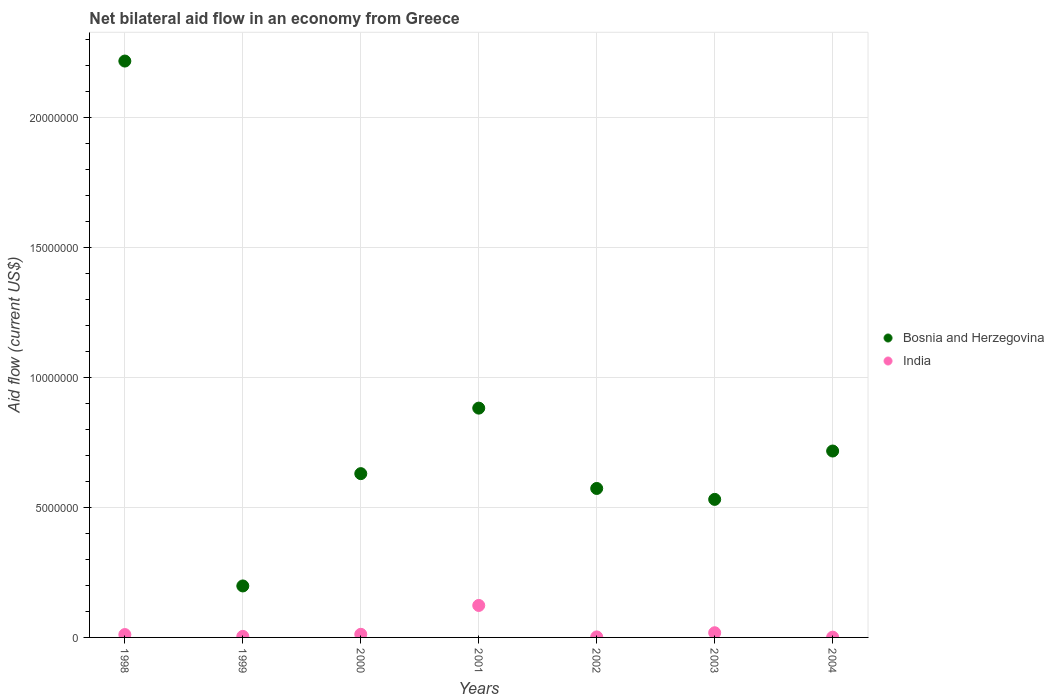How many different coloured dotlines are there?
Your response must be concise. 2. Across all years, what is the maximum net bilateral aid flow in Bosnia and Herzegovina?
Give a very brief answer. 2.22e+07. Across all years, what is the minimum net bilateral aid flow in India?
Offer a terse response. 10000. In which year was the net bilateral aid flow in Bosnia and Herzegovina maximum?
Your response must be concise. 1998. What is the total net bilateral aid flow in Bosnia and Herzegovina in the graph?
Offer a terse response. 5.75e+07. What is the difference between the net bilateral aid flow in Bosnia and Herzegovina in 1999 and that in 2002?
Make the answer very short. -3.75e+06. What is the difference between the net bilateral aid flow in Bosnia and Herzegovina in 1998 and the net bilateral aid flow in India in 2002?
Make the answer very short. 2.22e+07. What is the average net bilateral aid flow in Bosnia and Herzegovina per year?
Offer a very short reply. 8.21e+06. In the year 2002, what is the difference between the net bilateral aid flow in India and net bilateral aid flow in Bosnia and Herzegovina?
Give a very brief answer. -5.71e+06. What is the ratio of the net bilateral aid flow in India in 2000 to that in 2003?
Offer a terse response. 0.67. Is the difference between the net bilateral aid flow in India in 2000 and 2004 greater than the difference between the net bilateral aid flow in Bosnia and Herzegovina in 2000 and 2004?
Offer a terse response. Yes. What is the difference between the highest and the second highest net bilateral aid flow in Bosnia and Herzegovina?
Provide a succinct answer. 1.34e+07. What is the difference between the highest and the lowest net bilateral aid flow in India?
Give a very brief answer. 1.22e+06. Is the sum of the net bilateral aid flow in Bosnia and Herzegovina in 1999 and 2001 greater than the maximum net bilateral aid flow in India across all years?
Your answer should be compact. Yes. Does the net bilateral aid flow in Bosnia and Herzegovina monotonically increase over the years?
Provide a short and direct response. No. Is the net bilateral aid flow in Bosnia and Herzegovina strictly less than the net bilateral aid flow in India over the years?
Offer a terse response. No. How many dotlines are there?
Provide a succinct answer. 2. What is the difference between two consecutive major ticks on the Y-axis?
Offer a very short reply. 5.00e+06. Are the values on the major ticks of Y-axis written in scientific E-notation?
Provide a short and direct response. No. Does the graph contain grids?
Offer a terse response. Yes. Where does the legend appear in the graph?
Provide a succinct answer. Center right. How many legend labels are there?
Your answer should be compact. 2. How are the legend labels stacked?
Offer a terse response. Vertical. What is the title of the graph?
Ensure brevity in your answer.  Net bilateral aid flow in an economy from Greece. What is the label or title of the X-axis?
Your response must be concise. Years. What is the label or title of the Y-axis?
Provide a succinct answer. Aid flow (current US$). What is the Aid flow (current US$) of Bosnia and Herzegovina in 1998?
Your response must be concise. 2.22e+07. What is the Aid flow (current US$) of India in 1998?
Your answer should be compact. 1.10e+05. What is the Aid flow (current US$) in Bosnia and Herzegovina in 1999?
Provide a succinct answer. 1.98e+06. What is the Aid flow (current US$) in Bosnia and Herzegovina in 2000?
Ensure brevity in your answer.  6.30e+06. What is the Aid flow (current US$) of Bosnia and Herzegovina in 2001?
Ensure brevity in your answer.  8.82e+06. What is the Aid flow (current US$) of India in 2001?
Keep it short and to the point. 1.23e+06. What is the Aid flow (current US$) of Bosnia and Herzegovina in 2002?
Provide a short and direct response. 5.73e+06. What is the Aid flow (current US$) in Bosnia and Herzegovina in 2003?
Make the answer very short. 5.31e+06. What is the Aid flow (current US$) of Bosnia and Herzegovina in 2004?
Provide a succinct answer. 7.17e+06. What is the Aid flow (current US$) in India in 2004?
Give a very brief answer. 10000. Across all years, what is the maximum Aid flow (current US$) in Bosnia and Herzegovina?
Your answer should be compact. 2.22e+07. Across all years, what is the maximum Aid flow (current US$) of India?
Offer a very short reply. 1.23e+06. Across all years, what is the minimum Aid flow (current US$) of Bosnia and Herzegovina?
Offer a terse response. 1.98e+06. Across all years, what is the minimum Aid flow (current US$) of India?
Your response must be concise. 10000. What is the total Aid flow (current US$) in Bosnia and Herzegovina in the graph?
Provide a succinct answer. 5.75e+07. What is the total Aid flow (current US$) in India in the graph?
Your answer should be very brief. 1.71e+06. What is the difference between the Aid flow (current US$) of Bosnia and Herzegovina in 1998 and that in 1999?
Your answer should be compact. 2.02e+07. What is the difference between the Aid flow (current US$) of India in 1998 and that in 1999?
Your response must be concise. 7.00e+04. What is the difference between the Aid flow (current US$) of Bosnia and Herzegovina in 1998 and that in 2000?
Offer a very short reply. 1.59e+07. What is the difference between the Aid flow (current US$) of India in 1998 and that in 2000?
Offer a terse response. -10000. What is the difference between the Aid flow (current US$) in Bosnia and Herzegovina in 1998 and that in 2001?
Ensure brevity in your answer.  1.34e+07. What is the difference between the Aid flow (current US$) of India in 1998 and that in 2001?
Provide a short and direct response. -1.12e+06. What is the difference between the Aid flow (current US$) of Bosnia and Herzegovina in 1998 and that in 2002?
Your response must be concise. 1.64e+07. What is the difference between the Aid flow (current US$) in India in 1998 and that in 2002?
Keep it short and to the point. 9.00e+04. What is the difference between the Aid flow (current US$) in Bosnia and Herzegovina in 1998 and that in 2003?
Your answer should be very brief. 1.69e+07. What is the difference between the Aid flow (current US$) in India in 1998 and that in 2003?
Your answer should be very brief. -7.00e+04. What is the difference between the Aid flow (current US$) of Bosnia and Herzegovina in 1998 and that in 2004?
Offer a very short reply. 1.50e+07. What is the difference between the Aid flow (current US$) in India in 1998 and that in 2004?
Your response must be concise. 1.00e+05. What is the difference between the Aid flow (current US$) of Bosnia and Herzegovina in 1999 and that in 2000?
Offer a terse response. -4.32e+06. What is the difference between the Aid flow (current US$) in India in 1999 and that in 2000?
Keep it short and to the point. -8.00e+04. What is the difference between the Aid flow (current US$) of Bosnia and Herzegovina in 1999 and that in 2001?
Your answer should be compact. -6.84e+06. What is the difference between the Aid flow (current US$) in India in 1999 and that in 2001?
Provide a short and direct response. -1.19e+06. What is the difference between the Aid flow (current US$) of Bosnia and Herzegovina in 1999 and that in 2002?
Offer a terse response. -3.75e+06. What is the difference between the Aid flow (current US$) in Bosnia and Herzegovina in 1999 and that in 2003?
Give a very brief answer. -3.33e+06. What is the difference between the Aid flow (current US$) in Bosnia and Herzegovina in 1999 and that in 2004?
Offer a terse response. -5.19e+06. What is the difference between the Aid flow (current US$) of India in 1999 and that in 2004?
Your response must be concise. 3.00e+04. What is the difference between the Aid flow (current US$) of Bosnia and Herzegovina in 2000 and that in 2001?
Ensure brevity in your answer.  -2.52e+06. What is the difference between the Aid flow (current US$) in India in 2000 and that in 2001?
Provide a succinct answer. -1.11e+06. What is the difference between the Aid flow (current US$) of Bosnia and Herzegovina in 2000 and that in 2002?
Keep it short and to the point. 5.70e+05. What is the difference between the Aid flow (current US$) in India in 2000 and that in 2002?
Your answer should be compact. 1.00e+05. What is the difference between the Aid flow (current US$) of Bosnia and Herzegovina in 2000 and that in 2003?
Keep it short and to the point. 9.90e+05. What is the difference between the Aid flow (current US$) in Bosnia and Herzegovina in 2000 and that in 2004?
Keep it short and to the point. -8.70e+05. What is the difference between the Aid flow (current US$) of India in 2000 and that in 2004?
Give a very brief answer. 1.10e+05. What is the difference between the Aid flow (current US$) of Bosnia and Herzegovina in 2001 and that in 2002?
Provide a succinct answer. 3.09e+06. What is the difference between the Aid flow (current US$) in India in 2001 and that in 2002?
Make the answer very short. 1.21e+06. What is the difference between the Aid flow (current US$) in Bosnia and Herzegovina in 2001 and that in 2003?
Make the answer very short. 3.51e+06. What is the difference between the Aid flow (current US$) of India in 2001 and that in 2003?
Make the answer very short. 1.05e+06. What is the difference between the Aid flow (current US$) in Bosnia and Herzegovina in 2001 and that in 2004?
Your answer should be very brief. 1.65e+06. What is the difference between the Aid flow (current US$) of India in 2001 and that in 2004?
Give a very brief answer. 1.22e+06. What is the difference between the Aid flow (current US$) in Bosnia and Herzegovina in 2002 and that in 2003?
Your answer should be very brief. 4.20e+05. What is the difference between the Aid flow (current US$) of Bosnia and Herzegovina in 2002 and that in 2004?
Keep it short and to the point. -1.44e+06. What is the difference between the Aid flow (current US$) of India in 2002 and that in 2004?
Keep it short and to the point. 10000. What is the difference between the Aid flow (current US$) in Bosnia and Herzegovina in 2003 and that in 2004?
Provide a short and direct response. -1.86e+06. What is the difference between the Aid flow (current US$) in India in 2003 and that in 2004?
Give a very brief answer. 1.70e+05. What is the difference between the Aid flow (current US$) of Bosnia and Herzegovina in 1998 and the Aid flow (current US$) of India in 1999?
Provide a short and direct response. 2.21e+07. What is the difference between the Aid flow (current US$) of Bosnia and Herzegovina in 1998 and the Aid flow (current US$) of India in 2000?
Provide a succinct answer. 2.20e+07. What is the difference between the Aid flow (current US$) of Bosnia and Herzegovina in 1998 and the Aid flow (current US$) of India in 2001?
Provide a succinct answer. 2.09e+07. What is the difference between the Aid flow (current US$) in Bosnia and Herzegovina in 1998 and the Aid flow (current US$) in India in 2002?
Make the answer very short. 2.22e+07. What is the difference between the Aid flow (current US$) of Bosnia and Herzegovina in 1998 and the Aid flow (current US$) of India in 2003?
Provide a short and direct response. 2.20e+07. What is the difference between the Aid flow (current US$) in Bosnia and Herzegovina in 1998 and the Aid flow (current US$) in India in 2004?
Offer a very short reply. 2.22e+07. What is the difference between the Aid flow (current US$) in Bosnia and Herzegovina in 1999 and the Aid flow (current US$) in India in 2000?
Your answer should be compact. 1.86e+06. What is the difference between the Aid flow (current US$) in Bosnia and Herzegovina in 1999 and the Aid flow (current US$) in India in 2001?
Provide a short and direct response. 7.50e+05. What is the difference between the Aid flow (current US$) of Bosnia and Herzegovina in 1999 and the Aid flow (current US$) of India in 2002?
Make the answer very short. 1.96e+06. What is the difference between the Aid flow (current US$) of Bosnia and Herzegovina in 1999 and the Aid flow (current US$) of India in 2003?
Your answer should be very brief. 1.80e+06. What is the difference between the Aid flow (current US$) in Bosnia and Herzegovina in 1999 and the Aid flow (current US$) in India in 2004?
Provide a short and direct response. 1.97e+06. What is the difference between the Aid flow (current US$) of Bosnia and Herzegovina in 2000 and the Aid flow (current US$) of India in 2001?
Provide a succinct answer. 5.07e+06. What is the difference between the Aid flow (current US$) in Bosnia and Herzegovina in 2000 and the Aid flow (current US$) in India in 2002?
Ensure brevity in your answer.  6.28e+06. What is the difference between the Aid flow (current US$) of Bosnia and Herzegovina in 2000 and the Aid flow (current US$) of India in 2003?
Offer a very short reply. 6.12e+06. What is the difference between the Aid flow (current US$) of Bosnia and Herzegovina in 2000 and the Aid flow (current US$) of India in 2004?
Offer a very short reply. 6.29e+06. What is the difference between the Aid flow (current US$) of Bosnia and Herzegovina in 2001 and the Aid flow (current US$) of India in 2002?
Your answer should be compact. 8.80e+06. What is the difference between the Aid flow (current US$) in Bosnia and Herzegovina in 2001 and the Aid flow (current US$) in India in 2003?
Ensure brevity in your answer.  8.64e+06. What is the difference between the Aid flow (current US$) of Bosnia and Herzegovina in 2001 and the Aid flow (current US$) of India in 2004?
Give a very brief answer. 8.81e+06. What is the difference between the Aid flow (current US$) in Bosnia and Herzegovina in 2002 and the Aid flow (current US$) in India in 2003?
Your response must be concise. 5.55e+06. What is the difference between the Aid flow (current US$) in Bosnia and Herzegovina in 2002 and the Aid flow (current US$) in India in 2004?
Provide a succinct answer. 5.72e+06. What is the difference between the Aid flow (current US$) of Bosnia and Herzegovina in 2003 and the Aid flow (current US$) of India in 2004?
Your answer should be very brief. 5.30e+06. What is the average Aid flow (current US$) of Bosnia and Herzegovina per year?
Make the answer very short. 8.21e+06. What is the average Aid flow (current US$) of India per year?
Ensure brevity in your answer.  2.44e+05. In the year 1998, what is the difference between the Aid flow (current US$) of Bosnia and Herzegovina and Aid flow (current US$) of India?
Provide a succinct answer. 2.21e+07. In the year 1999, what is the difference between the Aid flow (current US$) of Bosnia and Herzegovina and Aid flow (current US$) of India?
Your response must be concise. 1.94e+06. In the year 2000, what is the difference between the Aid flow (current US$) of Bosnia and Herzegovina and Aid flow (current US$) of India?
Your answer should be very brief. 6.18e+06. In the year 2001, what is the difference between the Aid flow (current US$) in Bosnia and Herzegovina and Aid flow (current US$) in India?
Give a very brief answer. 7.59e+06. In the year 2002, what is the difference between the Aid flow (current US$) of Bosnia and Herzegovina and Aid flow (current US$) of India?
Offer a terse response. 5.71e+06. In the year 2003, what is the difference between the Aid flow (current US$) in Bosnia and Herzegovina and Aid flow (current US$) in India?
Ensure brevity in your answer.  5.13e+06. In the year 2004, what is the difference between the Aid flow (current US$) of Bosnia and Herzegovina and Aid flow (current US$) of India?
Give a very brief answer. 7.16e+06. What is the ratio of the Aid flow (current US$) in Bosnia and Herzegovina in 1998 to that in 1999?
Ensure brevity in your answer.  11.2. What is the ratio of the Aid flow (current US$) in India in 1998 to that in 1999?
Provide a short and direct response. 2.75. What is the ratio of the Aid flow (current US$) in Bosnia and Herzegovina in 1998 to that in 2000?
Your answer should be compact. 3.52. What is the ratio of the Aid flow (current US$) in Bosnia and Herzegovina in 1998 to that in 2001?
Offer a very short reply. 2.51. What is the ratio of the Aid flow (current US$) in India in 1998 to that in 2001?
Give a very brief answer. 0.09. What is the ratio of the Aid flow (current US$) of Bosnia and Herzegovina in 1998 to that in 2002?
Give a very brief answer. 3.87. What is the ratio of the Aid flow (current US$) of India in 1998 to that in 2002?
Your response must be concise. 5.5. What is the ratio of the Aid flow (current US$) in Bosnia and Herzegovina in 1998 to that in 2003?
Ensure brevity in your answer.  4.18. What is the ratio of the Aid flow (current US$) in India in 1998 to that in 2003?
Your response must be concise. 0.61. What is the ratio of the Aid flow (current US$) in Bosnia and Herzegovina in 1998 to that in 2004?
Your answer should be compact. 3.09. What is the ratio of the Aid flow (current US$) of Bosnia and Herzegovina in 1999 to that in 2000?
Give a very brief answer. 0.31. What is the ratio of the Aid flow (current US$) of Bosnia and Herzegovina in 1999 to that in 2001?
Your answer should be compact. 0.22. What is the ratio of the Aid flow (current US$) in India in 1999 to that in 2001?
Give a very brief answer. 0.03. What is the ratio of the Aid flow (current US$) of Bosnia and Herzegovina in 1999 to that in 2002?
Provide a short and direct response. 0.35. What is the ratio of the Aid flow (current US$) of Bosnia and Herzegovina in 1999 to that in 2003?
Provide a short and direct response. 0.37. What is the ratio of the Aid flow (current US$) of India in 1999 to that in 2003?
Offer a very short reply. 0.22. What is the ratio of the Aid flow (current US$) of Bosnia and Herzegovina in 1999 to that in 2004?
Give a very brief answer. 0.28. What is the ratio of the Aid flow (current US$) of India in 1999 to that in 2004?
Your answer should be compact. 4. What is the ratio of the Aid flow (current US$) in India in 2000 to that in 2001?
Your answer should be compact. 0.1. What is the ratio of the Aid flow (current US$) in Bosnia and Herzegovina in 2000 to that in 2002?
Make the answer very short. 1.1. What is the ratio of the Aid flow (current US$) of India in 2000 to that in 2002?
Offer a terse response. 6. What is the ratio of the Aid flow (current US$) in Bosnia and Herzegovina in 2000 to that in 2003?
Make the answer very short. 1.19. What is the ratio of the Aid flow (current US$) in Bosnia and Herzegovina in 2000 to that in 2004?
Keep it short and to the point. 0.88. What is the ratio of the Aid flow (current US$) of Bosnia and Herzegovina in 2001 to that in 2002?
Provide a succinct answer. 1.54. What is the ratio of the Aid flow (current US$) of India in 2001 to that in 2002?
Your answer should be very brief. 61.5. What is the ratio of the Aid flow (current US$) in Bosnia and Herzegovina in 2001 to that in 2003?
Offer a very short reply. 1.66. What is the ratio of the Aid flow (current US$) of India in 2001 to that in 2003?
Provide a succinct answer. 6.83. What is the ratio of the Aid flow (current US$) in Bosnia and Herzegovina in 2001 to that in 2004?
Offer a terse response. 1.23. What is the ratio of the Aid flow (current US$) in India in 2001 to that in 2004?
Keep it short and to the point. 123. What is the ratio of the Aid flow (current US$) of Bosnia and Herzegovina in 2002 to that in 2003?
Offer a terse response. 1.08. What is the ratio of the Aid flow (current US$) in India in 2002 to that in 2003?
Offer a terse response. 0.11. What is the ratio of the Aid flow (current US$) of Bosnia and Herzegovina in 2002 to that in 2004?
Make the answer very short. 0.8. What is the ratio of the Aid flow (current US$) in Bosnia and Herzegovina in 2003 to that in 2004?
Your answer should be very brief. 0.74. What is the difference between the highest and the second highest Aid flow (current US$) of Bosnia and Herzegovina?
Offer a terse response. 1.34e+07. What is the difference between the highest and the second highest Aid flow (current US$) in India?
Offer a very short reply. 1.05e+06. What is the difference between the highest and the lowest Aid flow (current US$) of Bosnia and Herzegovina?
Offer a very short reply. 2.02e+07. What is the difference between the highest and the lowest Aid flow (current US$) of India?
Provide a short and direct response. 1.22e+06. 